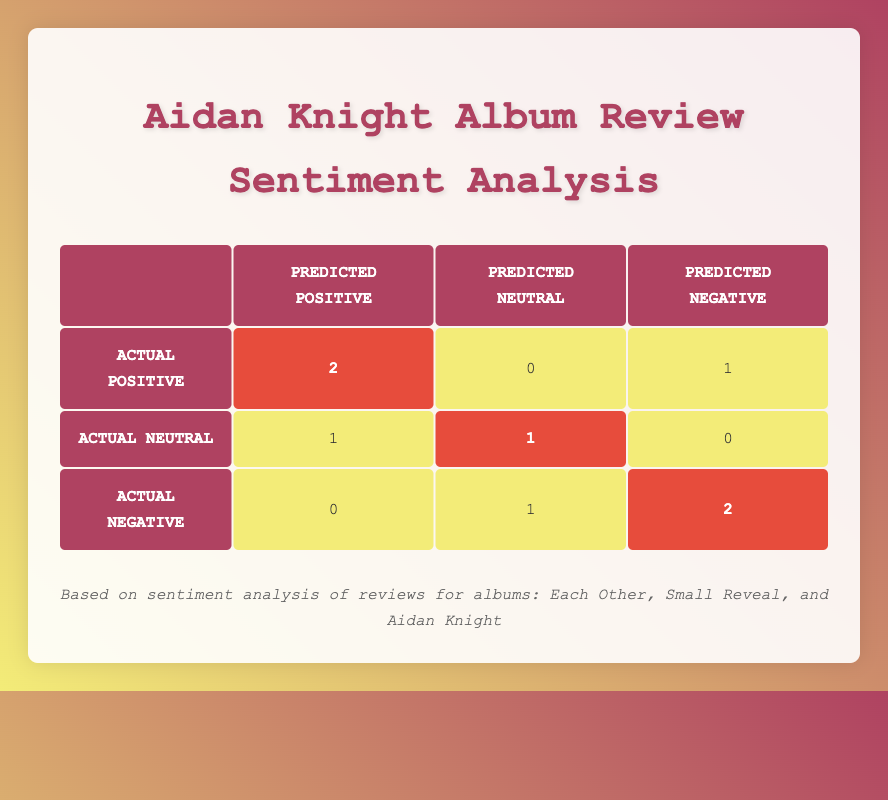What is the total number of reviews that predicted a positive sentiment? There are two entries in the table where the predicted sentiment is positive: 2 from Actual Positive and 1 from Actual Neutral, totaling 3.
Answer: 3 How many reviews were accurately predicted as neutral? The table shows 1 review that had an actual sentiment of neutral and was also predicted as neutral.
Answer: 1 What is the total number of negative reviews predicted? The table indicates there are two entries for predicted negative: 1 from Actual Positive and 2 from Actual Negative, which equals 3 total negative predictions.
Answer: 3 Did any album review get a negative prediction when the actual sentiment was positive? Yes, the table indicates there was one review where the predicted sentiment was negative, but the actual sentiment was positive.
Answer: Yes Which category had the lowest number of predictions? By looking at the table, the predicted neutral has the lowest total with only 2 entries (1 actual positive and 1 actual negative).
Answer: Predicted Neutral How many actual positive reviews were misclassified as negative? The table shows 1 actual positive review was incorrectly predicted as negative.
Answer: 1 What is the proportion of accurately predicted positive reviews to the total number of reviews? There are 2 accurately predicted positive reviews out of a total of 8 reviews, giving a proportion of 2/8 = 0.25 or 25%.
Answer: 25% What is the total number of reviews where the predicted sentiment matched the actual sentiment? The table shows 4 entries (2 from Actual Positive + 1 from Actual Neutral + 1 from Actual Negative) matched the predicted sentiment.
Answer: 4 How many reviews had an actual negative sentiment? According to the table, there are 3 reviews that had an actual sentiment of negative.
Answer: 3 Is the number of negative predictions greater than the number of neutral predictions? Yes, there are 3 negative predictions compared to only 2 neutral predictions.
Answer: Yes 